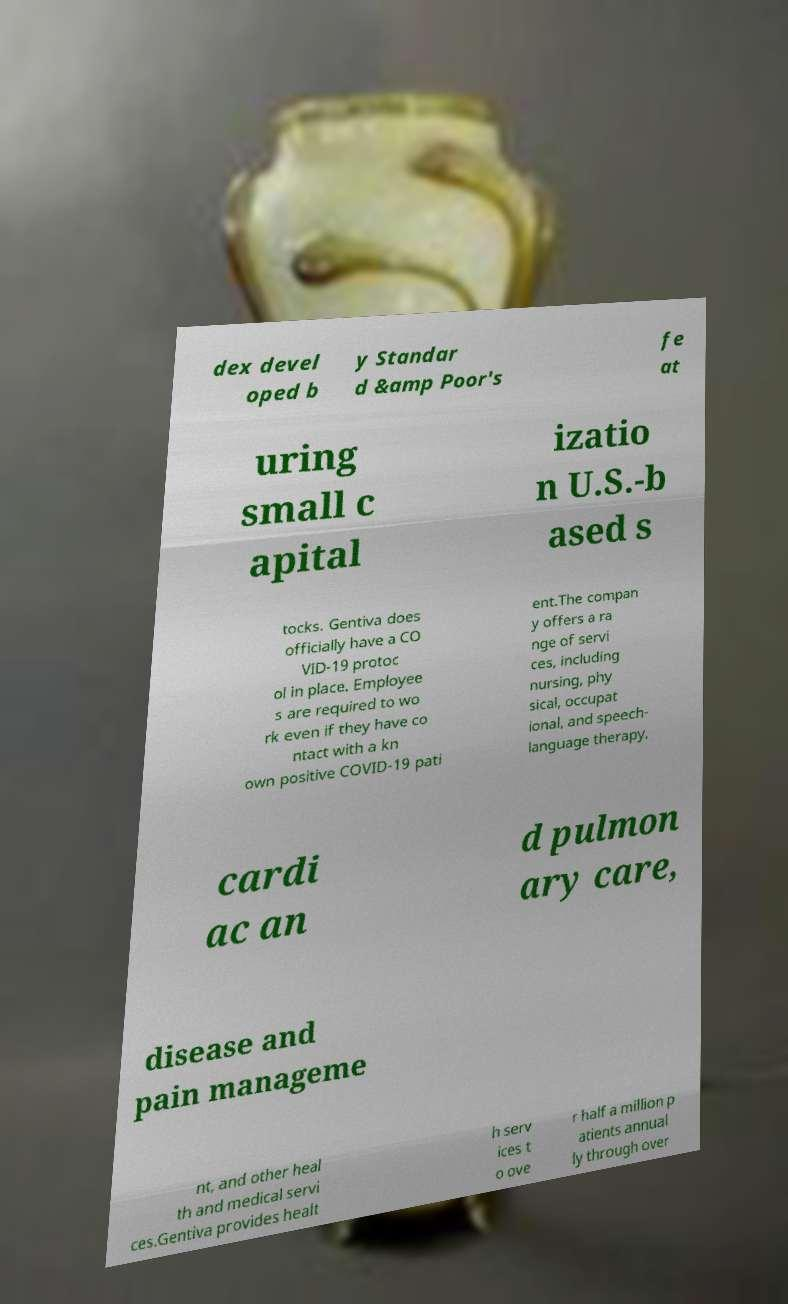Please identify and transcribe the text found in this image. dex devel oped b y Standar d &amp Poor's fe at uring small c apital izatio n U.S.-b ased s tocks. Gentiva does officially have a CO VID-19 protoc ol in place. Employee s are required to wo rk even if they have co ntact with a kn own positive COVID-19 pati ent.The compan y offers a ra nge of servi ces, including nursing, phy sical, occupat ional, and speech- language therapy, cardi ac an d pulmon ary care, disease and pain manageme nt, and other heal th and medical servi ces.Gentiva provides healt h serv ices t o ove r half a million p atients annual ly through over 